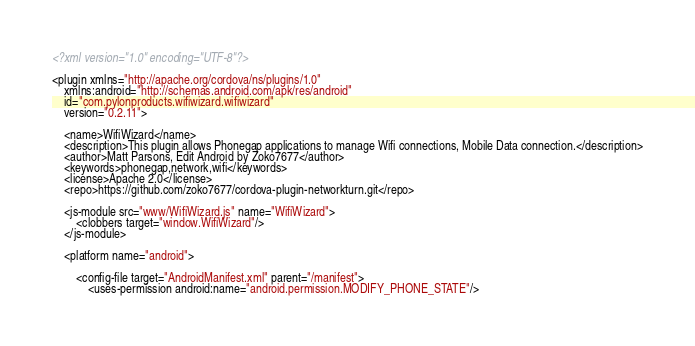<code> <loc_0><loc_0><loc_500><loc_500><_XML_><?xml version="1.0" encoding="UTF-8"?>

<plugin xmlns="http://apache.org/cordova/ns/plugins/1.0"
	xmlns:android="http://schemas.android.com/apk/res/android"
	id="com.pylonproducts.wifiwizard.wifiwizard"
	version="0.2.11">

    <name>WifiWizard</name>
    <description>This plugin allows Phonegap applications to manage Wifi connections, Mobile Data connection.</description>
	<author>Matt Parsons, Edit Android by Zoko7677</author>
	<keywords>phonegap,network,wifi</keywords>
    <license>Apache 2.0</license>
	<repo>https://github.com/zoko7677/cordova-plugin-networkturn.git</repo>

    <js-module src="www/WifiWizard.js" name="WifiWizard">
    	<clobbers target="window.WifiWizard"/>
    </js-module>

    <platform name="android">

		<config-file target="AndroidManifest.xml" parent="/manifest">
			<uses-permission android:name="android.permission.MODIFY_PHONE_STATE"/>			</code> 